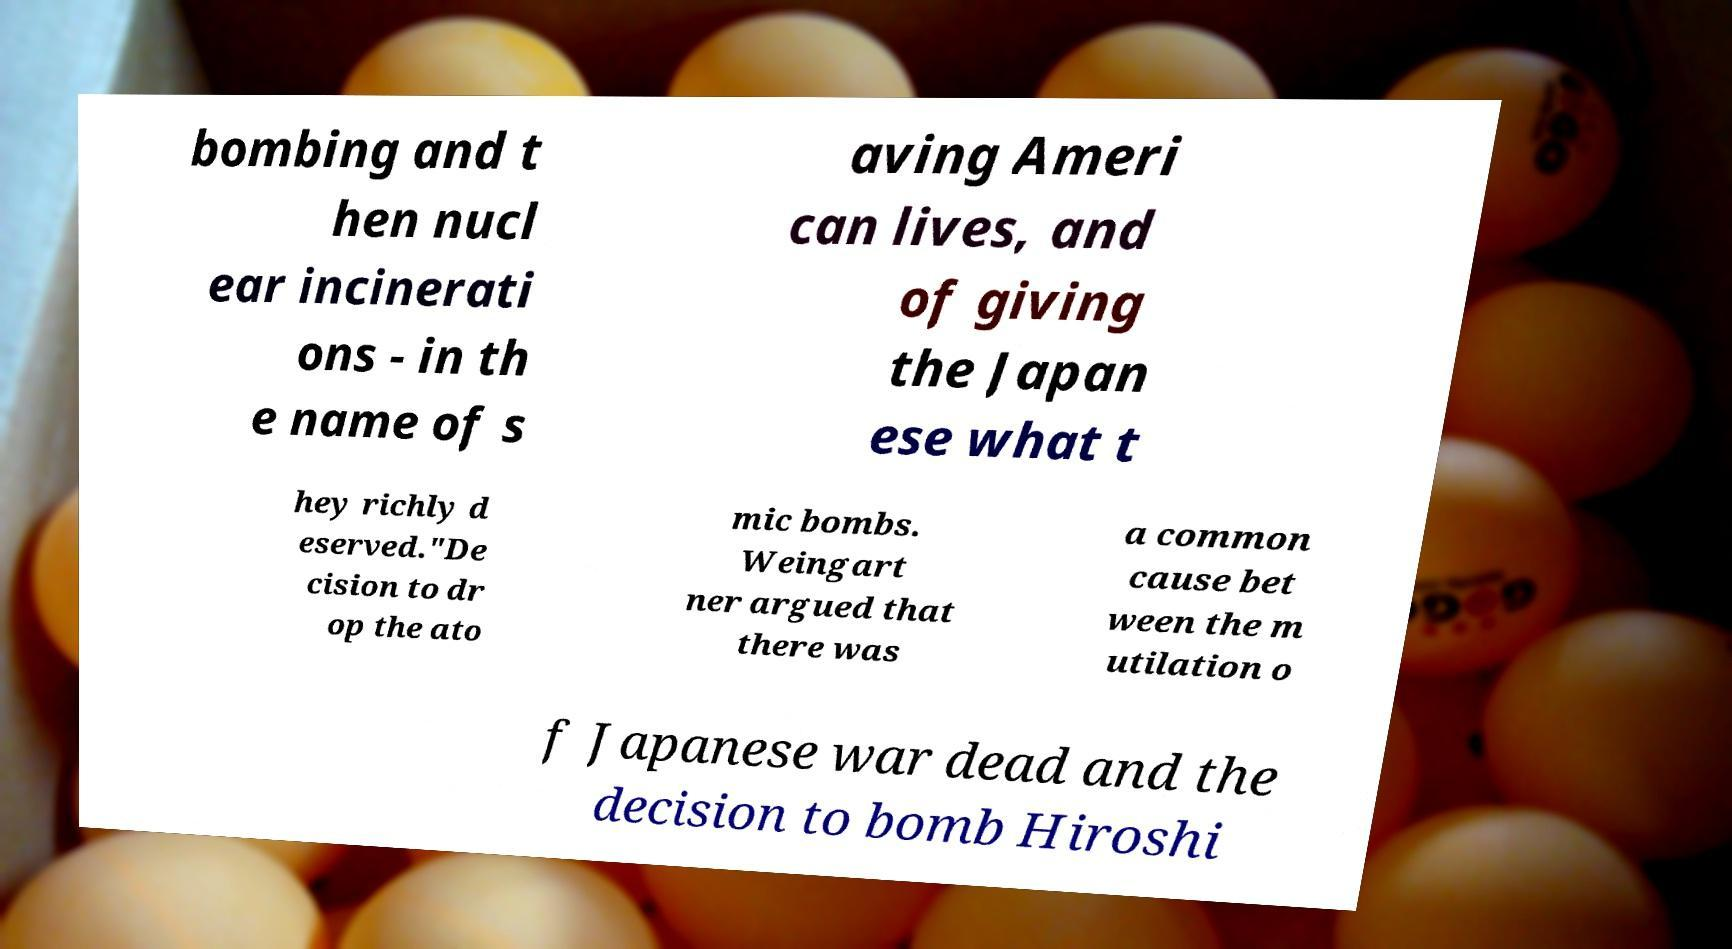Can you read and provide the text displayed in the image?This photo seems to have some interesting text. Can you extract and type it out for me? bombing and t hen nucl ear incinerati ons - in th e name of s aving Ameri can lives, and of giving the Japan ese what t hey richly d eserved."De cision to dr op the ato mic bombs. Weingart ner argued that there was a common cause bet ween the m utilation o f Japanese war dead and the decision to bomb Hiroshi 